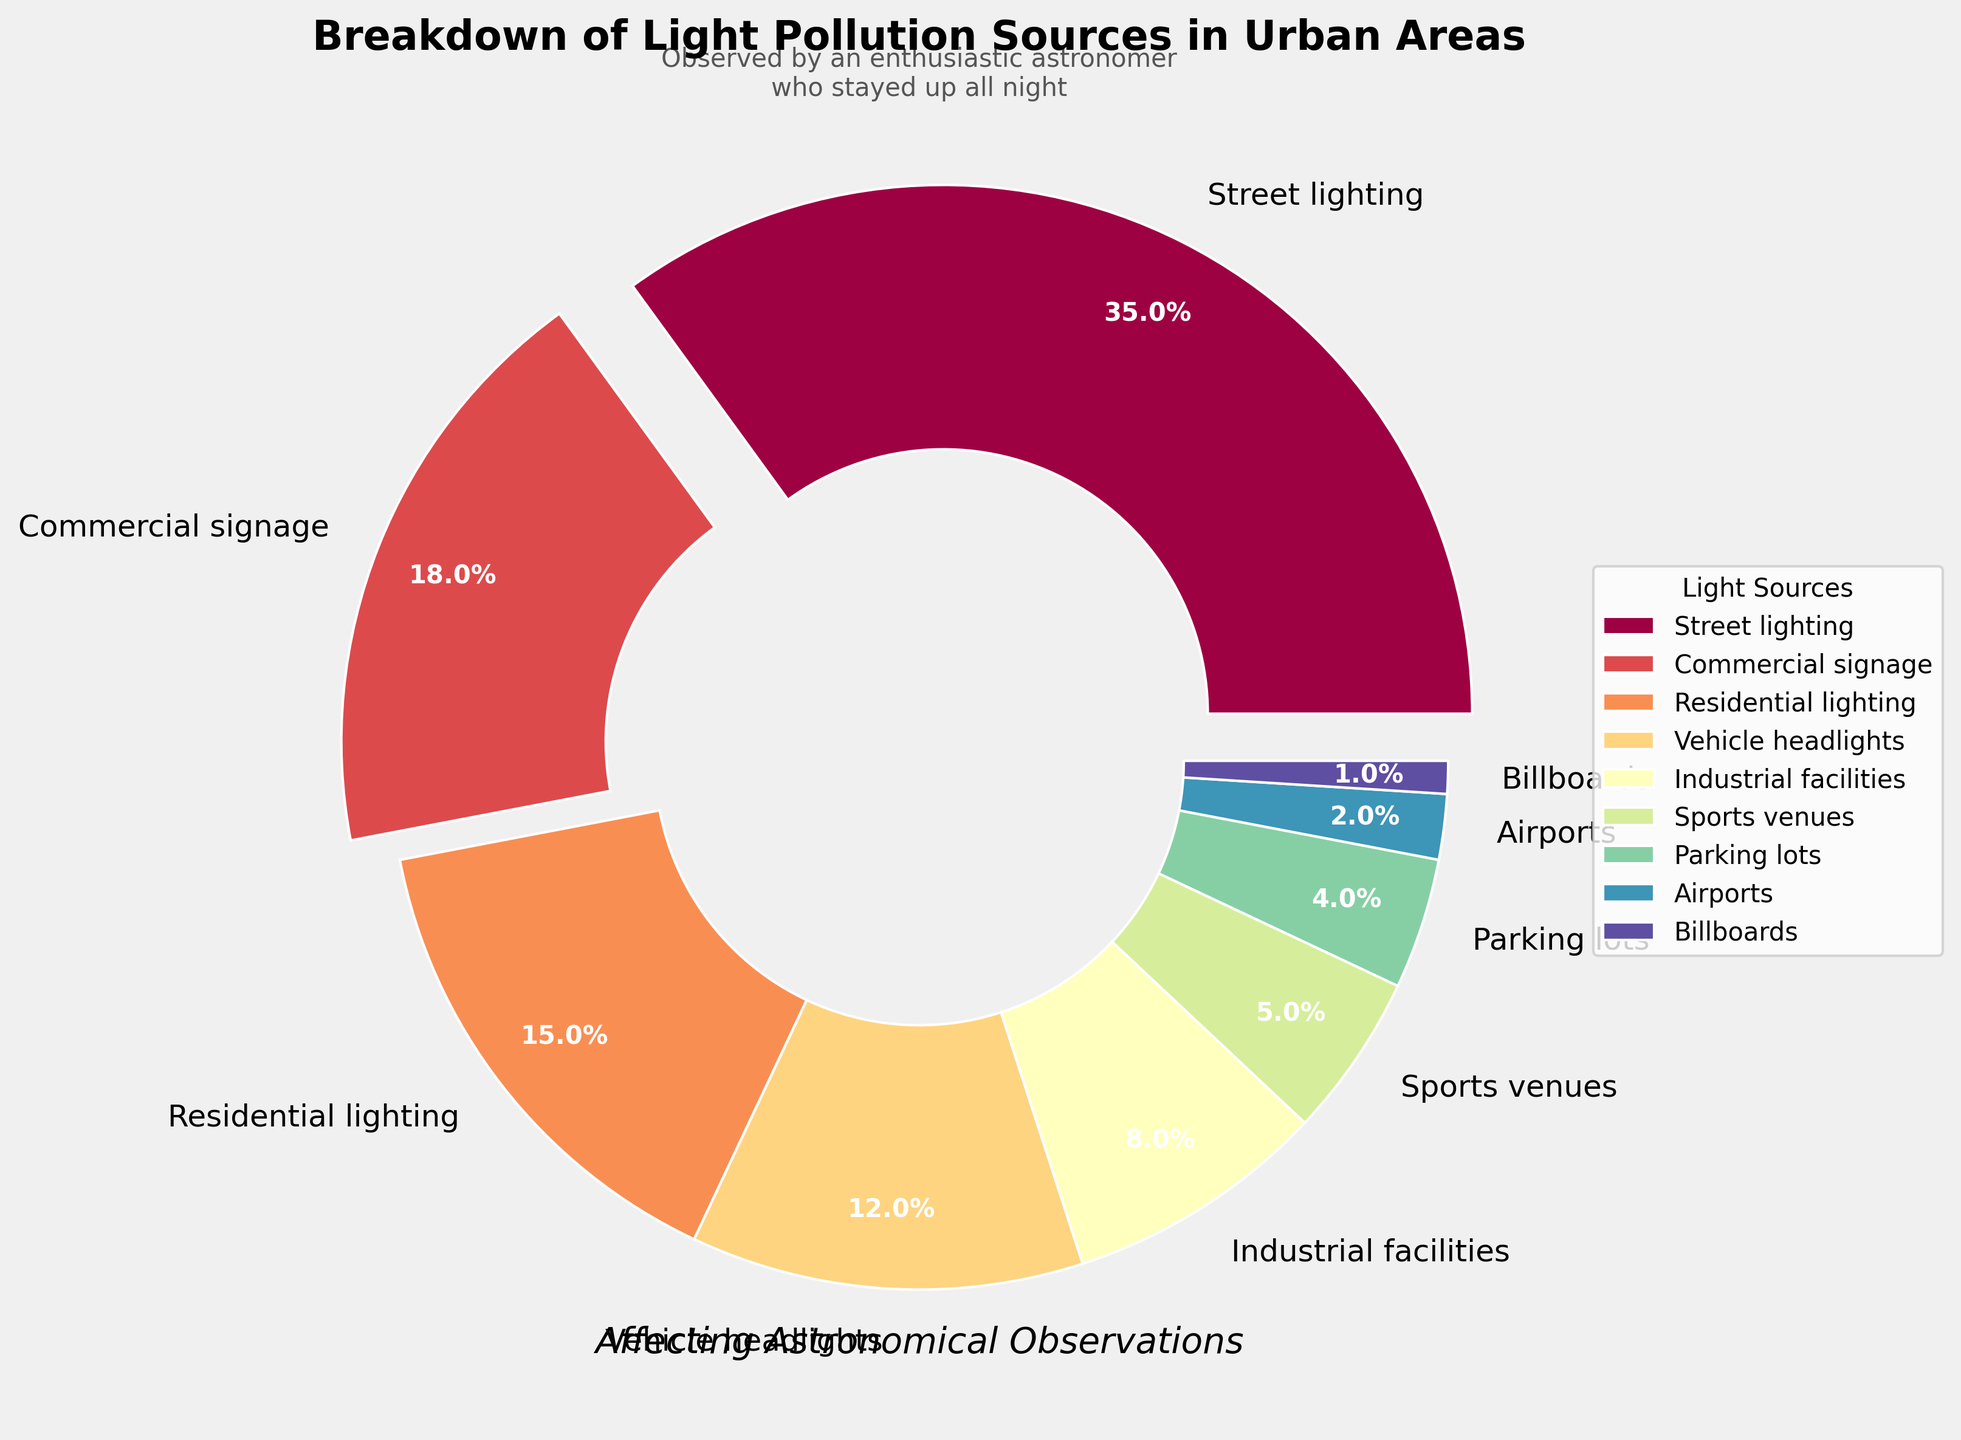What source of light pollution contributes the most? By examining the pie chart, the largest segment is for Street lighting, highlighted with a slight explosion for emphasis. This segment accounts for 35% of the total light pollution.
Answer: Street lighting Which two categories have the smallest contributions combined? Observing the chart, the two smallest segments are Billboards (1%) and Airports (2%). Adding these together results in a combined contribution of 1% + 2% = 3%.
Answer: Billboards and Airports What is the total percentage of light pollution contributed by Residential lighting, Vehicle headlights, and Parking lots? From the pie chart, Residential lighting contributes 15%, Vehicle headlights 12%, and Parking lots 4%. Adding these together, 15% + 12% + 4% = 31%.
Answer: 31% Which source of light pollution is represented by a blue segment? Looking at the pie chart, the segment colored in blue represents Vehicle headlights, which contributes 12% of the light pollution.
Answer: Vehicle headlights Is the contribution from commercial signage greater or less than that from industrial facilities? By examining the pie chart, the contribution from Commercial signage is 18%, whereas Industrial facilities contribute 8%. Since 18% is greater than 8%, Commercial signage has a greater contribution.
Answer: Greater Which three sources, when combined, make up more than half of the total light pollution? Checking the chart, the three largest contributions are Street lighting (35%), Commercial signage (18%), and Residential lighting (15%). The sum of these is 35% + 18% + 15% = 68%, which is more than 50%.
Answer: Street lighting, Commercial signage, and Residential lighting What is the difference in percentage between the contributions from Street lighting and Sports venues? Street lighting contributes 35% and Sports venues 5%. The difference is calculated as 35% - 5% = 30%.
Answer: 30% Does the pie chart highlight any segments distinctly? Evaluating the visual attributes of the chart, the Street lighting segment is highlighted with an explostion effect to draw attention to its significant contribution of 35%.
Answer: Yes How does the contribution of Sports venues compare with that of Parking lots? Sports venues contribute 5%, whereas Parking lots contribute 4%. Since 5% is slightly greater than 4%, the contribution from Sports venues is higher.
Answer: Sports venues What is the combined percentage of contributions from sources that individually contribute less than 10%? Combining Industrial facilities (8%), Sports venues (5%), Parking lots (4%), Airports (2%), and Billboards (1%) results in 8% + 5% + 4% + 2% + 1% = 20%.
Answer: 20% 